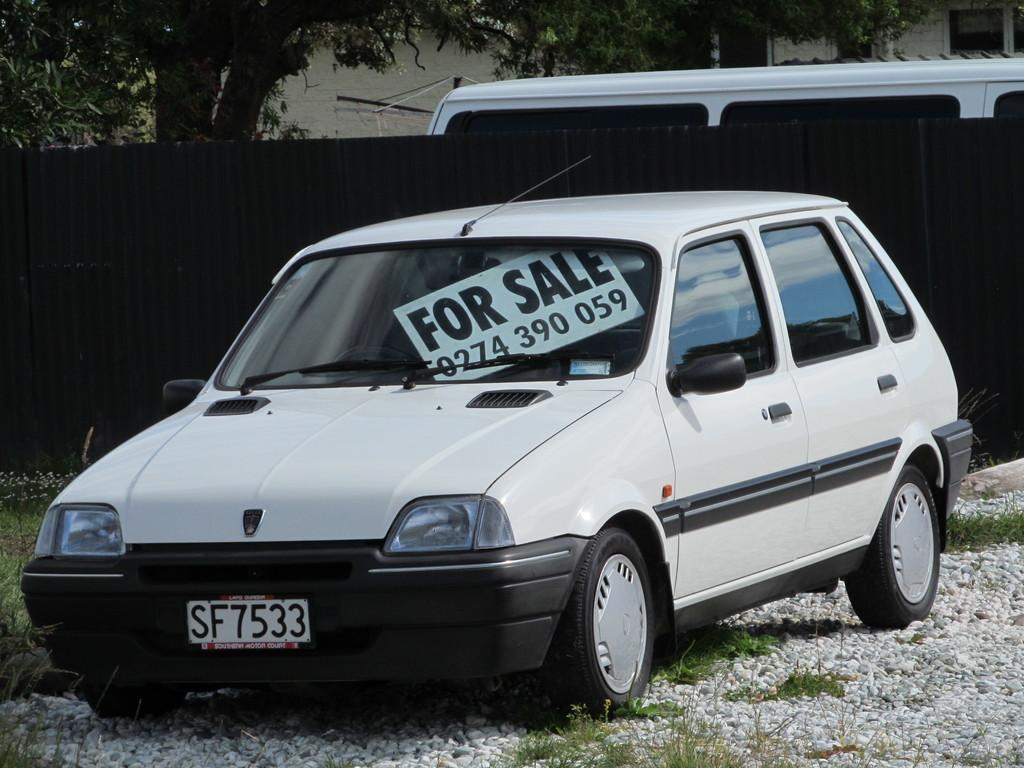Provide a one-sentence caption for the provided image. A car for sale with a front tag number SF7533. 